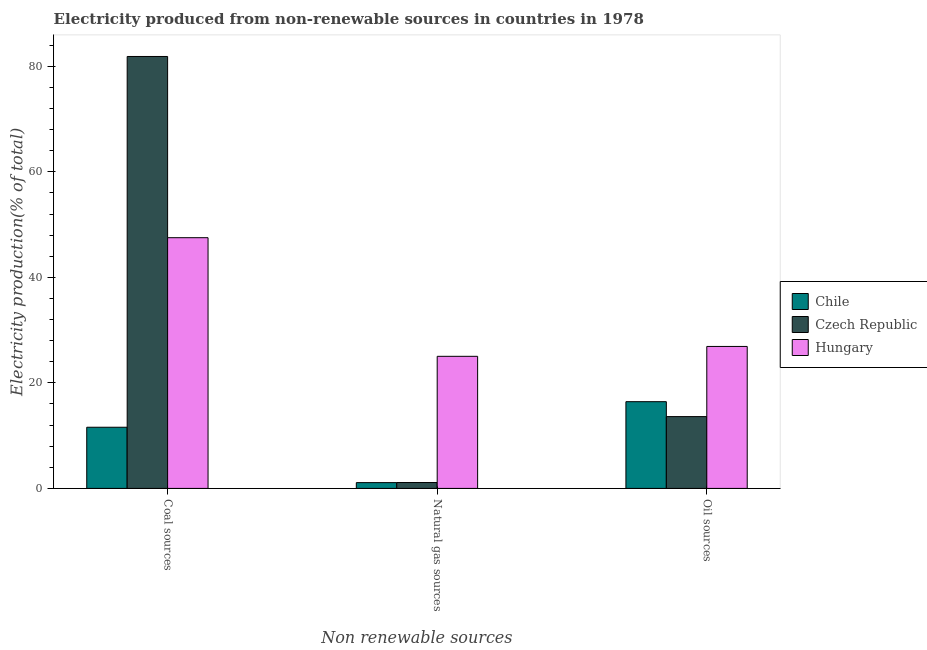Are the number of bars per tick equal to the number of legend labels?
Your response must be concise. Yes. Are the number of bars on each tick of the X-axis equal?
Keep it short and to the point. Yes. How many bars are there on the 3rd tick from the right?
Provide a short and direct response. 3. What is the label of the 2nd group of bars from the left?
Ensure brevity in your answer.  Natural gas sources. What is the percentage of electricity produced by natural gas in Hungary?
Offer a very short reply. 25.04. Across all countries, what is the maximum percentage of electricity produced by natural gas?
Your response must be concise. 25.04. Across all countries, what is the minimum percentage of electricity produced by natural gas?
Give a very brief answer. 1.1. In which country was the percentage of electricity produced by natural gas maximum?
Make the answer very short. Hungary. In which country was the percentage of electricity produced by natural gas minimum?
Make the answer very short. Chile. What is the total percentage of electricity produced by natural gas in the graph?
Offer a terse response. 27.25. What is the difference between the percentage of electricity produced by oil sources in Chile and that in Hungary?
Provide a succinct answer. -10.47. What is the difference between the percentage of electricity produced by natural gas in Chile and the percentage of electricity produced by oil sources in Czech Republic?
Give a very brief answer. -12.51. What is the average percentage of electricity produced by natural gas per country?
Your answer should be compact. 9.08. What is the difference between the percentage of electricity produced by natural gas and percentage of electricity produced by oil sources in Czech Republic?
Your response must be concise. -12.49. In how many countries, is the percentage of electricity produced by natural gas greater than 24 %?
Your answer should be compact. 1. What is the ratio of the percentage of electricity produced by coal in Hungary to that in Czech Republic?
Make the answer very short. 0.58. Is the percentage of electricity produced by natural gas in Chile less than that in Czech Republic?
Provide a short and direct response. Yes. What is the difference between the highest and the second highest percentage of electricity produced by coal?
Offer a terse response. 34.35. What is the difference between the highest and the lowest percentage of electricity produced by oil sources?
Make the answer very short. 13.3. Is the sum of the percentage of electricity produced by natural gas in Czech Republic and Chile greater than the maximum percentage of electricity produced by oil sources across all countries?
Give a very brief answer. No. What does the 2nd bar from the left in Coal sources represents?
Your answer should be compact. Czech Republic. What does the 3rd bar from the right in Oil sources represents?
Provide a short and direct response. Chile. How many bars are there?
Keep it short and to the point. 9. Are all the bars in the graph horizontal?
Offer a very short reply. No. How many countries are there in the graph?
Give a very brief answer. 3. What is the difference between two consecutive major ticks on the Y-axis?
Make the answer very short. 20. Are the values on the major ticks of Y-axis written in scientific E-notation?
Keep it short and to the point. No. How many legend labels are there?
Provide a short and direct response. 3. What is the title of the graph?
Your response must be concise. Electricity produced from non-renewable sources in countries in 1978. What is the label or title of the X-axis?
Offer a terse response. Non renewable sources. What is the Electricity production(% of total) in Chile in Coal sources?
Your response must be concise. 11.59. What is the Electricity production(% of total) in Czech Republic in Coal sources?
Keep it short and to the point. 81.86. What is the Electricity production(% of total) in Hungary in Coal sources?
Provide a succinct answer. 47.52. What is the Electricity production(% of total) in Chile in Natural gas sources?
Keep it short and to the point. 1.1. What is the Electricity production(% of total) of Czech Republic in Natural gas sources?
Make the answer very short. 1.12. What is the Electricity production(% of total) of Hungary in Natural gas sources?
Keep it short and to the point. 25.04. What is the Electricity production(% of total) in Chile in Oil sources?
Offer a very short reply. 16.44. What is the Electricity production(% of total) in Czech Republic in Oil sources?
Offer a terse response. 13.61. What is the Electricity production(% of total) in Hungary in Oil sources?
Make the answer very short. 26.91. Across all Non renewable sources, what is the maximum Electricity production(% of total) in Chile?
Keep it short and to the point. 16.44. Across all Non renewable sources, what is the maximum Electricity production(% of total) of Czech Republic?
Provide a short and direct response. 81.86. Across all Non renewable sources, what is the maximum Electricity production(% of total) of Hungary?
Your answer should be very brief. 47.52. Across all Non renewable sources, what is the minimum Electricity production(% of total) of Chile?
Provide a short and direct response. 1.1. Across all Non renewable sources, what is the minimum Electricity production(% of total) in Czech Republic?
Offer a terse response. 1.12. Across all Non renewable sources, what is the minimum Electricity production(% of total) of Hungary?
Provide a succinct answer. 25.04. What is the total Electricity production(% of total) in Chile in the graph?
Your answer should be very brief. 29.13. What is the total Electricity production(% of total) in Czech Republic in the graph?
Offer a terse response. 96.59. What is the total Electricity production(% of total) of Hungary in the graph?
Ensure brevity in your answer.  99.46. What is the difference between the Electricity production(% of total) of Chile in Coal sources and that in Natural gas sources?
Offer a very short reply. 10.49. What is the difference between the Electricity production(% of total) in Czech Republic in Coal sources and that in Natural gas sources?
Provide a short and direct response. 80.74. What is the difference between the Electricity production(% of total) of Hungary in Coal sources and that in Natural gas sources?
Provide a short and direct response. 22.48. What is the difference between the Electricity production(% of total) in Chile in Coal sources and that in Oil sources?
Provide a succinct answer. -4.85. What is the difference between the Electricity production(% of total) of Czech Republic in Coal sources and that in Oil sources?
Ensure brevity in your answer.  68.25. What is the difference between the Electricity production(% of total) of Hungary in Coal sources and that in Oil sources?
Your answer should be very brief. 20.61. What is the difference between the Electricity production(% of total) in Chile in Natural gas sources and that in Oil sources?
Offer a very short reply. -15.34. What is the difference between the Electricity production(% of total) of Czech Republic in Natural gas sources and that in Oil sources?
Your answer should be very brief. -12.49. What is the difference between the Electricity production(% of total) of Hungary in Natural gas sources and that in Oil sources?
Provide a short and direct response. -1.87. What is the difference between the Electricity production(% of total) of Chile in Coal sources and the Electricity production(% of total) of Czech Republic in Natural gas sources?
Give a very brief answer. 10.47. What is the difference between the Electricity production(% of total) of Chile in Coal sources and the Electricity production(% of total) of Hungary in Natural gas sources?
Make the answer very short. -13.44. What is the difference between the Electricity production(% of total) in Czech Republic in Coal sources and the Electricity production(% of total) in Hungary in Natural gas sources?
Provide a succinct answer. 56.83. What is the difference between the Electricity production(% of total) in Chile in Coal sources and the Electricity production(% of total) in Czech Republic in Oil sources?
Make the answer very short. -2.02. What is the difference between the Electricity production(% of total) in Chile in Coal sources and the Electricity production(% of total) in Hungary in Oil sources?
Give a very brief answer. -15.31. What is the difference between the Electricity production(% of total) in Czech Republic in Coal sources and the Electricity production(% of total) in Hungary in Oil sources?
Provide a short and direct response. 54.95. What is the difference between the Electricity production(% of total) of Chile in Natural gas sources and the Electricity production(% of total) of Czech Republic in Oil sources?
Make the answer very short. -12.51. What is the difference between the Electricity production(% of total) of Chile in Natural gas sources and the Electricity production(% of total) of Hungary in Oil sources?
Your answer should be very brief. -25.81. What is the difference between the Electricity production(% of total) in Czech Republic in Natural gas sources and the Electricity production(% of total) in Hungary in Oil sources?
Give a very brief answer. -25.79. What is the average Electricity production(% of total) of Chile per Non renewable sources?
Your answer should be very brief. 9.71. What is the average Electricity production(% of total) in Czech Republic per Non renewable sources?
Offer a terse response. 32.2. What is the average Electricity production(% of total) of Hungary per Non renewable sources?
Your answer should be compact. 33.15. What is the difference between the Electricity production(% of total) in Chile and Electricity production(% of total) in Czech Republic in Coal sources?
Ensure brevity in your answer.  -70.27. What is the difference between the Electricity production(% of total) of Chile and Electricity production(% of total) of Hungary in Coal sources?
Make the answer very short. -35.92. What is the difference between the Electricity production(% of total) in Czech Republic and Electricity production(% of total) in Hungary in Coal sources?
Ensure brevity in your answer.  34.35. What is the difference between the Electricity production(% of total) of Chile and Electricity production(% of total) of Czech Republic in Natural gas sources?
Ensure brevity in your answer.  -0.02. What is the difference between the Electricity production(% of total) of Chile and Electricity production(% of total) of Hungary in Natural gas sources?
Give a very brief answer. -23.94. What is the difference between the Electricity production(% of total) in Czech Republic and Electricity production(% of total) in Hungary in Natural gas sources?
Your answer should be compact. -23.92. What is the difference between the Electricity production(% of total) of Chile and Electricity production(% of total) of Czech Republic in Oil sources?
Provide a short and direct response. 2.83. What is the difference between the Electricity production(% of total) in Chile and Electricity production(% of total) in Hungary in Oil sources?
Your response must be concise. -10.47. What is the difference between the Electricity production(% of total) of Czech Republic and Electricity production(% of total) of Hungary in Oil sources?
Keep it short and to the point. -13.3. What is the ratio of the Electricity production(% of total) in Chile in Coal sources to that in Natural gas sources?
Ensure brevity in your answer.  10.54. What is the ratio of the Electricity production(% of total) in Czech Republic in Coal sources to that in Natural gas sources?
Your answer should be compact. 73.22. What is the ratio of the Electricity production(% of total) in Hungary in Coal sources to that in Natural gas sources?
Your response must be concise. 1.9. What is the ratio of the Electricity production(% of total) of Chile in Coal sources to that in Oil sources?
Provide a succinct answer. 0.71. What is the ratio of the Electricity production(% of total) of Czech Republic in Coal sources to that in Oil sources?
Provide a succinct answer. 6.01. What is the ratio of the Electricity production(% of total) of Hungary in Coal sources to that in Oil sources?
Give a very brief answer. 1.77. What is the ratio of the Electricity production(% of total) in Chile in Natural gas sources to that in Oil sources?
Ensure brevity in your answer.  0.07. What is the ratio of the Electricity production(% of total) of Czech Republic in Natural gas sources to that in Oil sources?
Give a very brief answer. 0.08. What is the ratio of the Electricity production(% of total) of Hungary in Natural gas sources to that in Oil sources?
Provide a short and direct response. 0.93. What is the difference between the highest and the second highest Electricity production(% of total) of Chile?
Ensure brevity in your answer.  4.85. What is the difference between the highest and the second highest Electricity production(% of total) in Czech Republic?
Your answer should be very brief. 68.25. What is the difference between the highest and the second highest Electricity production(% of total) of Hungary?
Offer a terse response. 20.61. What is the difference between the highest and the lowest Electricity production(% of total) in Chile?
Offer a terse response. 15.34. What is the difference between the highest and the lowest Electricity production(% of total) of Czech Republic?
Offer a terse response. 80.74. What is the difference between the highest and the lowest Electricity production(% of total) of Hungary?
Offer a very short reply. 22.48. 